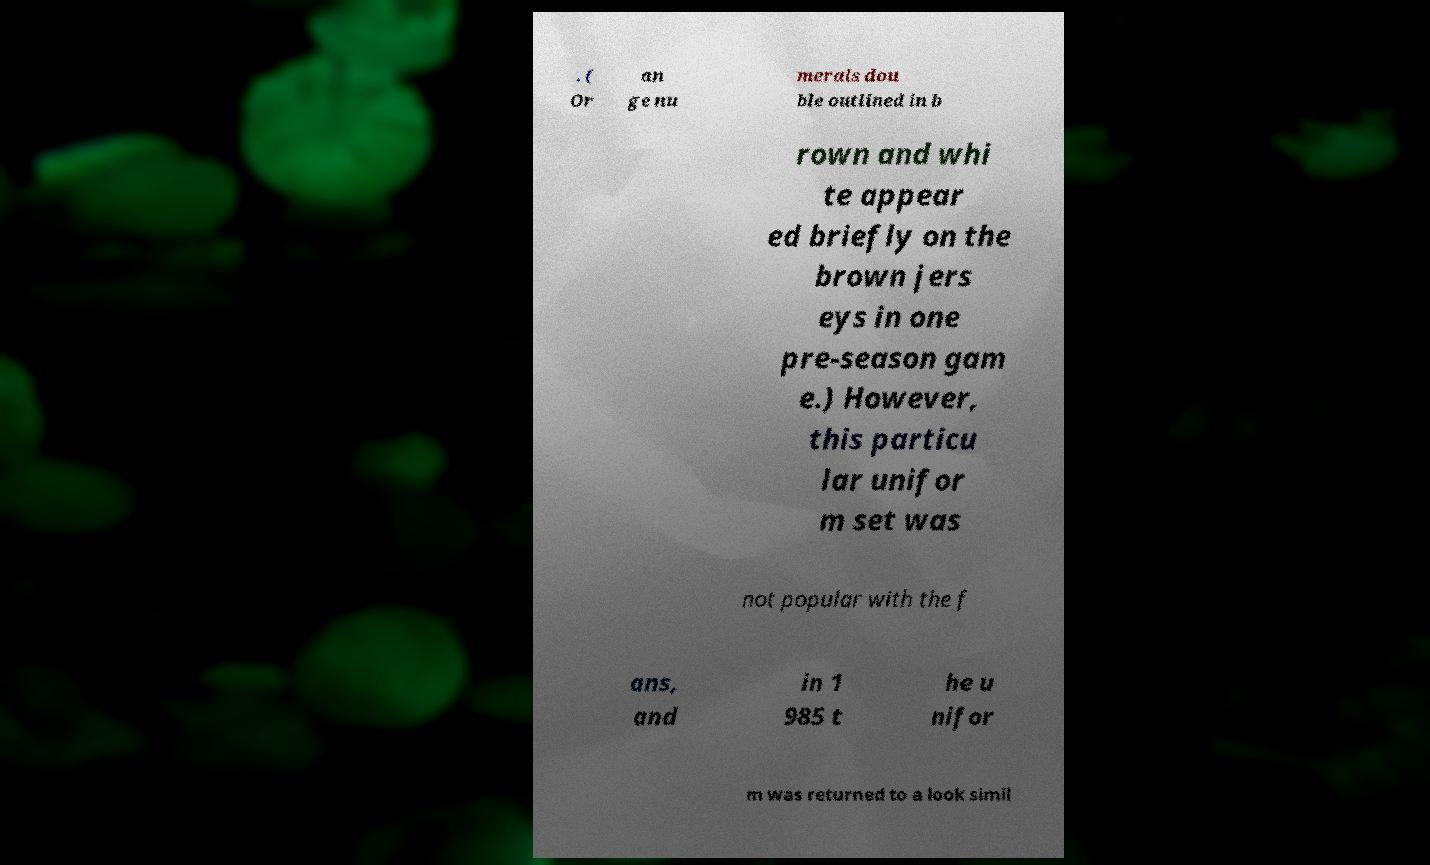What messages or text are displayed in this image? I need them in a readable, typed format. . ( Or an ge nu merals dou ble outlined in b rown and whi te appear ed briefly on the brown jers eys in one pre-season gam e.) However, this particu lar unifor m set was not popular with the f ans, and in 1 985 t he u nifor m was returned to a look simil 